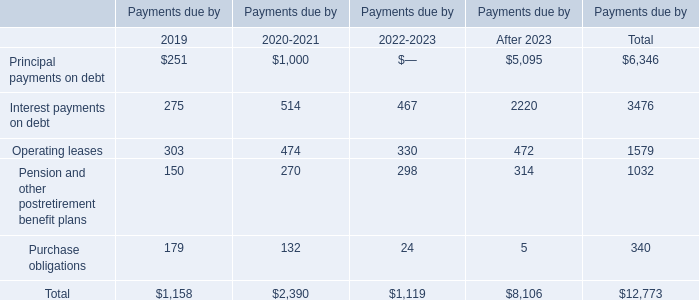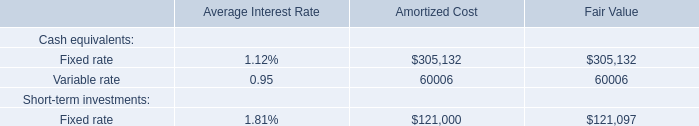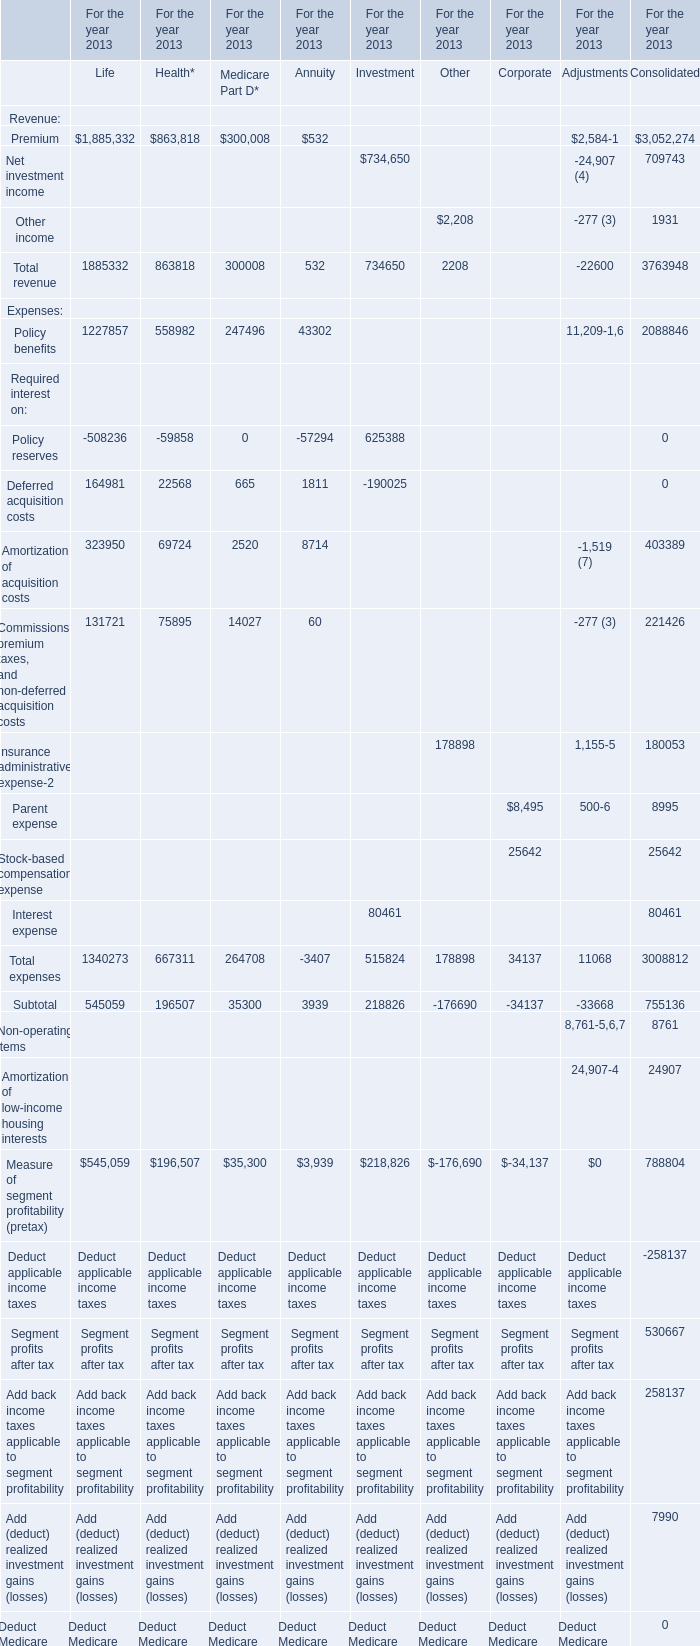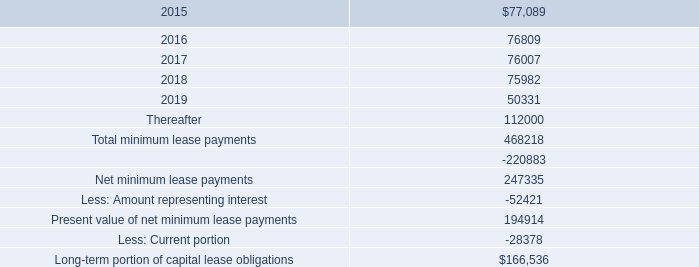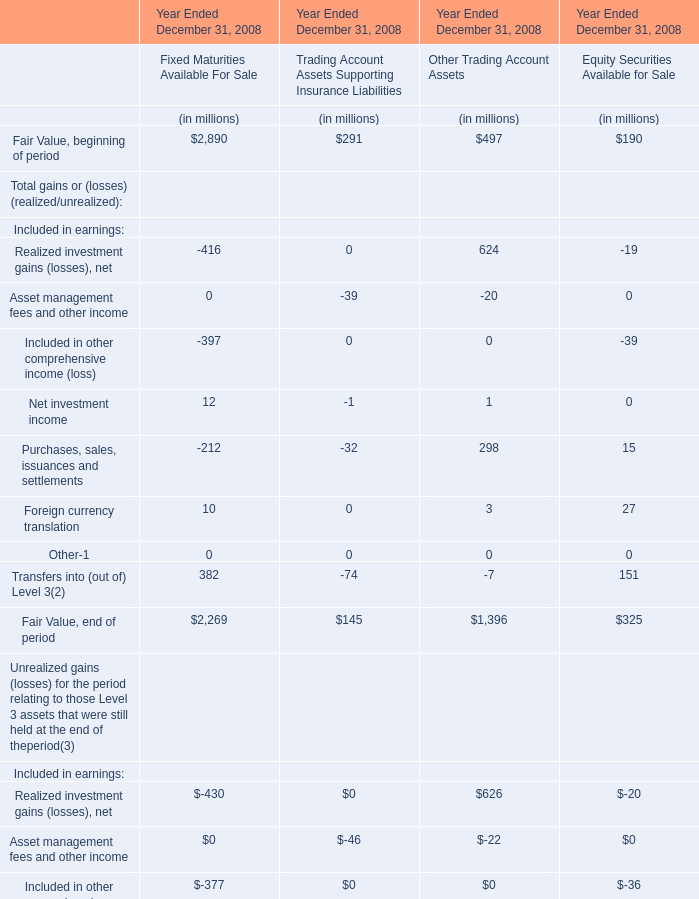What is the sum of Total revenue of Life, Total expenses of Life, Total revenue of Investment and Total expenses of Investment for the year 2013? 
Computations: (((1885332 + 1340273) + 734650) + 515824)
Answer: 4476079.0. 